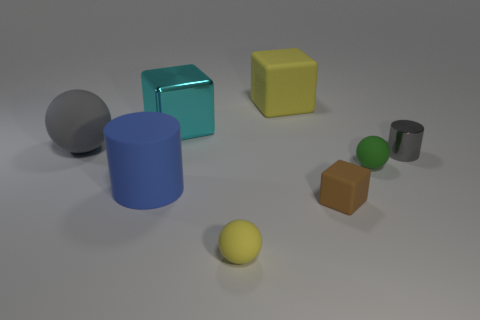There is a shiny object in front of the shiny block; what color is it?
Offer a very short reply. Gray. Is there another rubber thing that has the same size as the cyan object?
Ensure brevity in your answer.  Yes. There is a cylinder that is the same size as the brown rubber cube; what is its material?
Provide a succinct answer. Metal. How many objects are either cubes that are in front of the large gray ball or cylinders to the right of the blue thing?
Your answer should be compact. 2. Is there a big cyan shiny object of the same shape as the small brown thing?
Give a very brief answer. Yes. What is the material of the big ball that is the same color as the small metallic cylinder?
Your response must be concise. Rubber. What number of matte things are either large yellow balls or cyan objects?
Provide a short and direct response. 0. The green object has what shape?
Ensure brevity in your answer.  Sphere. What number of big balls have the same material as the cyan thing?
Give a very brief answer. 0. The other block that is made of the same material as the small block is what color?
Ensure brevity in your answer.  Yellow. 